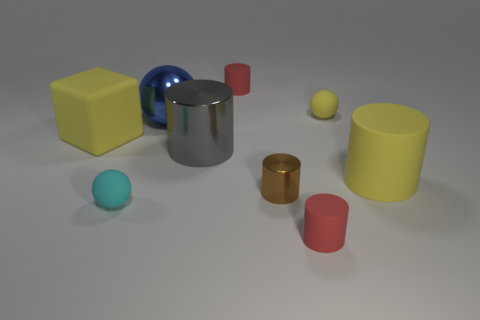There is a tiny red rubber thing that is behind the cyan ball; what is its shape?
Your response must be concise. Cylinder. The brown metallic object that is the same size as the cyan thing is what shape?
Give a very brief answer. Cylinder. There is a matte object right of the tiny matte sphere that is behind the large shiny object in front of the large yellow cube; what is its color?
Give a very brief answer. Yellow. Is the large blue metal thing the same shape as the cyan thing?
Keep it short and to the point. Yes. Are there an equal number of tiny metallic objects right of the small brown metallic thing and small yellow shiny things?
Provide a succinct answer. Yes. What number of other things are made of the same material as the yellow block?
Keep it short and to the point. 5. Is the size of the rubber ball in front of the tiny metallic cylinder the same as the yellow cylinder in front of the large yellow rubber cube?
Provide a short and direct response. No. How many objects are either tiny yellow things behind the big gray cylinder or matte objects that are on the right side of the brown metal cylinder?
Keep it short and to the point. 3. There is a matte ball that is right of the large blue shiny thing; does it have the same color as the matte ball that is on the left side of the big blue shiny sphere?
Provide a short and direct response. No. What number of rubber things are either small yellow spheres or tiny yellow cylinders?
Ensure brevity in your answer.  1. 